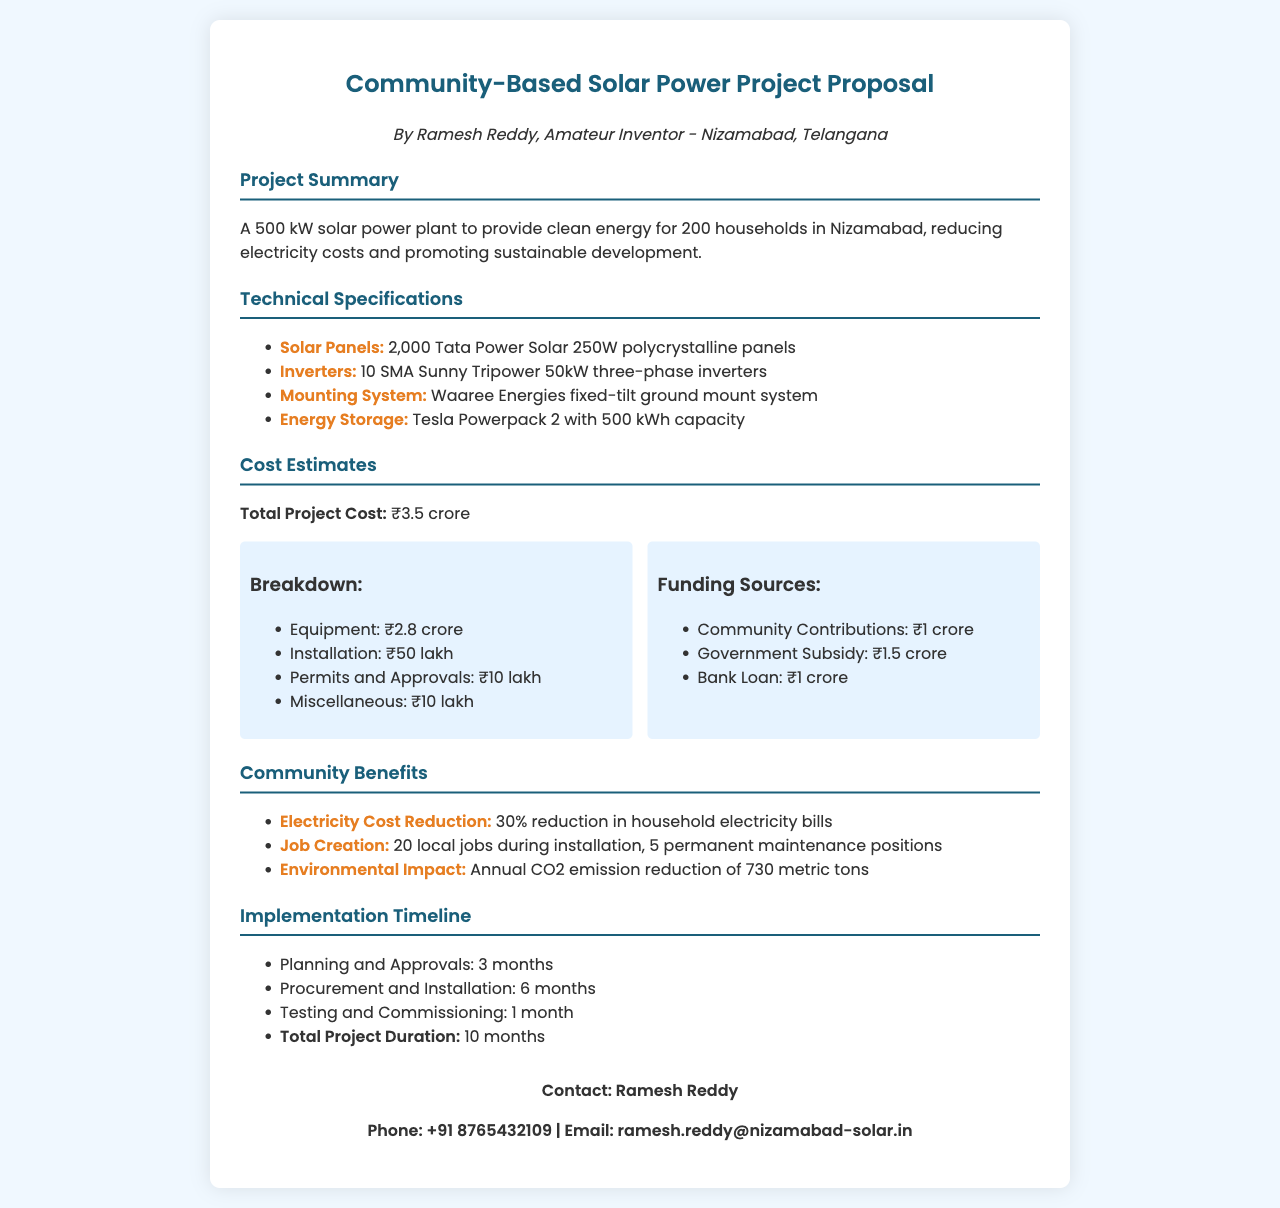What is the total project cost? The total project cost is specified in the document, which is ₹3.5 crore.
Answer: ₹3.5 crore How many households will benefit from the solar power plant? The project summary states that 200 households will benefit from the solar power plant.
Answer: 200 households What type of solar panels will be used? The technical specifications list the specific type of panels which are Tata Power Solar 250W polycrystalline panels.
Answer: Tata Power Solar 250W polycrystalline panels How many months are allocated for planning and approvals? The implementation timeline provides the duration for planning and approvals as 3 months.
Answer: 3 months What is the expected reduction in household electricity bills? The community benefits section highlights a 30% reduction in household electricity bills from the solar power project.
Answer: 30% What is the capacity of the energy storage system? The document specifies the energy storage capacity as 500 kWh in the technical specifications.
Answer: 500 kWh How many local jobs will be created during installation? The community benefits section states that 20 local jobs will be created during the installation phase.
Answer: 20 local jobs Who is the author of this proposal? The fax indicates that the author of the proposal is Ramesh Reddy.
Answer: Ramesh Reddy 